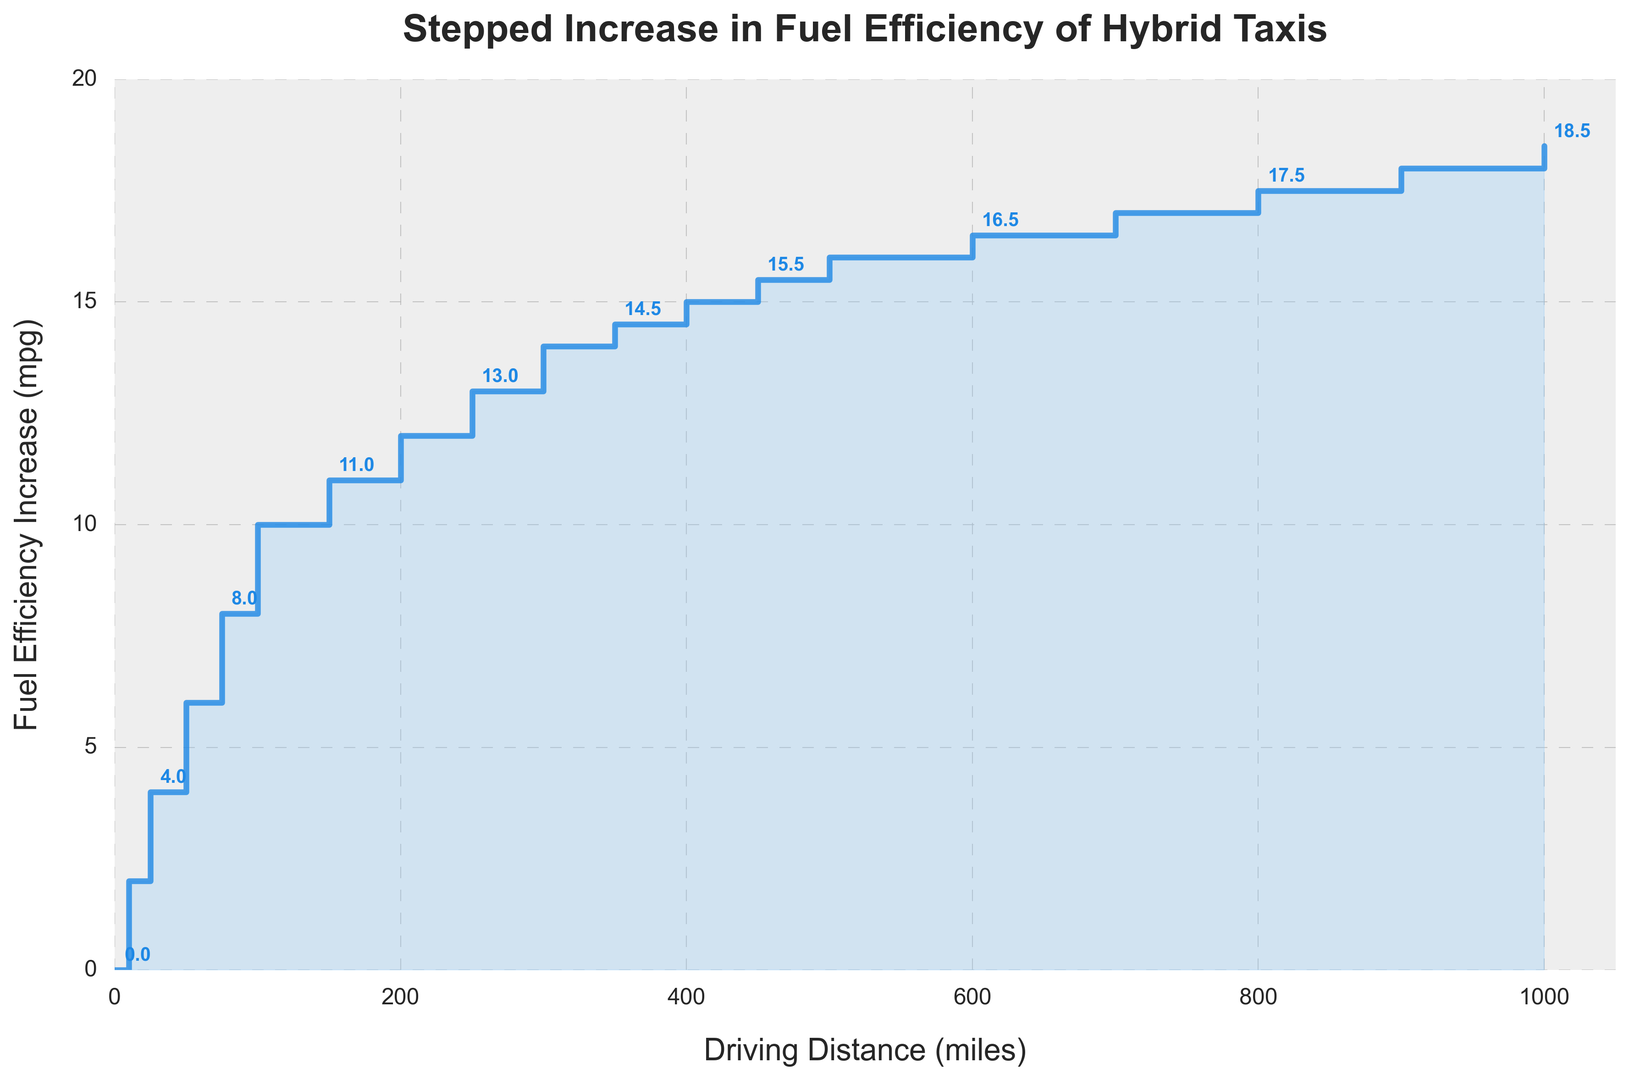What is the increase in fuel efficiency from 0 to 100 miles? We look at the values on the y-axis corresponding to driving distances 0 and 100 miles. The increase goes from 0 mpg to 10 mpg. Thus, the change in fuel efficiency is 10 - 0 = 10 mpg.
Answer: 10 mpg How much more efficient is the vehicle at 500 miles compared to 250 miles? The fuel efficiency increase at 500 miles is 16 mpg, and at 250 miles it is 13 mpg. The difference is 16 - 13 = 3 mpg.
Answer: 3 mpg At what distance does the fuel efficiency increase reach 15 mpg? Looking at the stair-step plot, the fuel efficiency increase reaches 15 mpg at 400 miles.
Answer: 400 miles Which distance interval shows the highest single increase in fuel efficiency? The highest single increase can be determined by finding the largest step between consecutive points. From 0 to 10 miles, the increase is 2 mpg (2-0), from 10 to 25 miles it is 2 mpg (4-2), and so forth until the interval with the largest increase is found. The largest step occurs between 100 and 150 miles with a 1 mpg increase per 50 miles.
Answer: 100-150 miles What is the average increase in fuel efficiency per mile between 0 and 1000 miles? To find the average increase per mile, we look at the total increase in fuel efficiency at 1000 miles, which is 18.5 mpg. Given the total distance of 1000 miles, the average increase per mile is 18.5 / 1000 = 0.0185 mpg per mile.
Answer: 0.0185 mpg per mile What visual attribute indicates that the increase in fuel efficiency stabilizes eventually? The plot levels out as the steps become smaller and less steep towards the higher distances, indicating a stabilization in the increase of fuel efficiency.
Answer: Steps become smaller Is the increase in fuel efficiency more significant at shorter or longer distances? By observing the step heights, we see that the earlier steps (shorter distances) have larger increments compared to the later steps (longer distances). This indicates that the increase in fuel efficiency is more significant at shorter distances.
Answer: Shorter distances What is the median fuel efficiency increase around the 500-mile mark? The fuel efficiency values before and after 500 miles are 16 and 16.5 mpg, respectively. Therefore, the median of these two values (average) is (16 + 16.5) / 2 = 16.25 mpg.
Answer: 16.25 mpg 